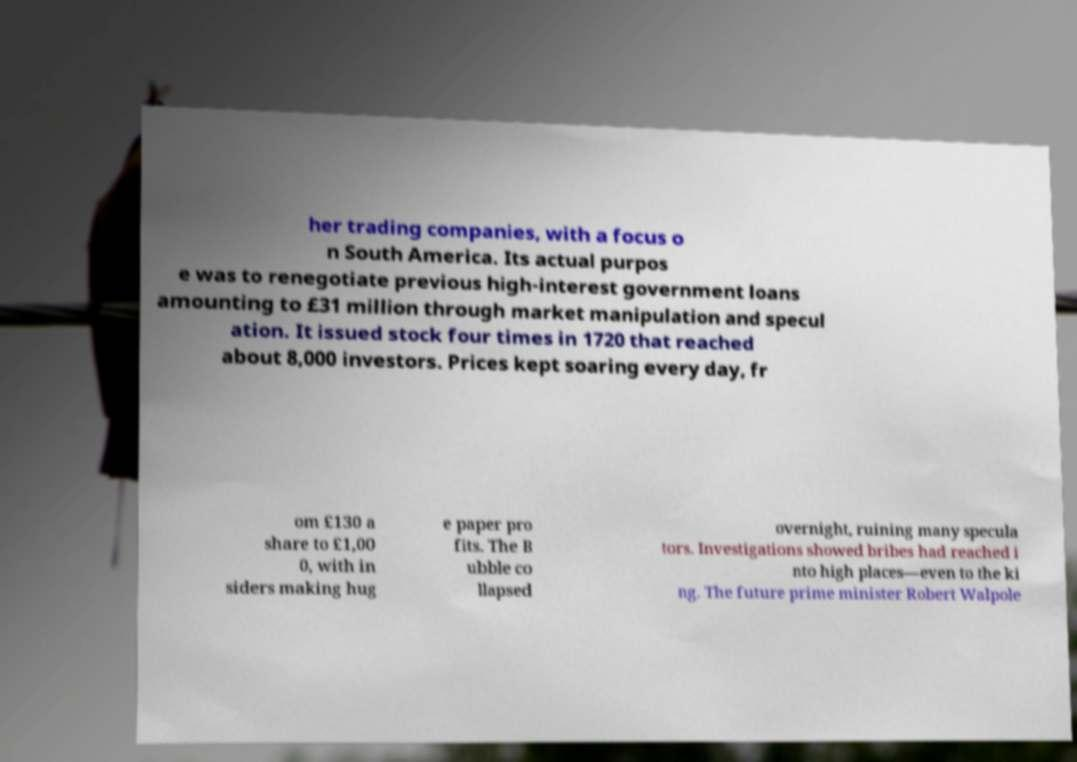Can you accurately transcribe the text from the provided image for me? her trading companies, with a focus o n South America. Its actual purpos e was to renegotiate previous high-interest government loans amounting to £31 million through market manipulation and specul ation. It issued stock four times in 1720 that reached about 8,000 investors. Prices kept soaring every day, fr om £130 a share to £1,00 0, with in siders making hug e paper pro fits. The B ubble co llapsed overnight, ruining many specula tors. Investigations showed bribes had reached i nto high places—even to the ki ng. The future prime minister Robert Walpole 